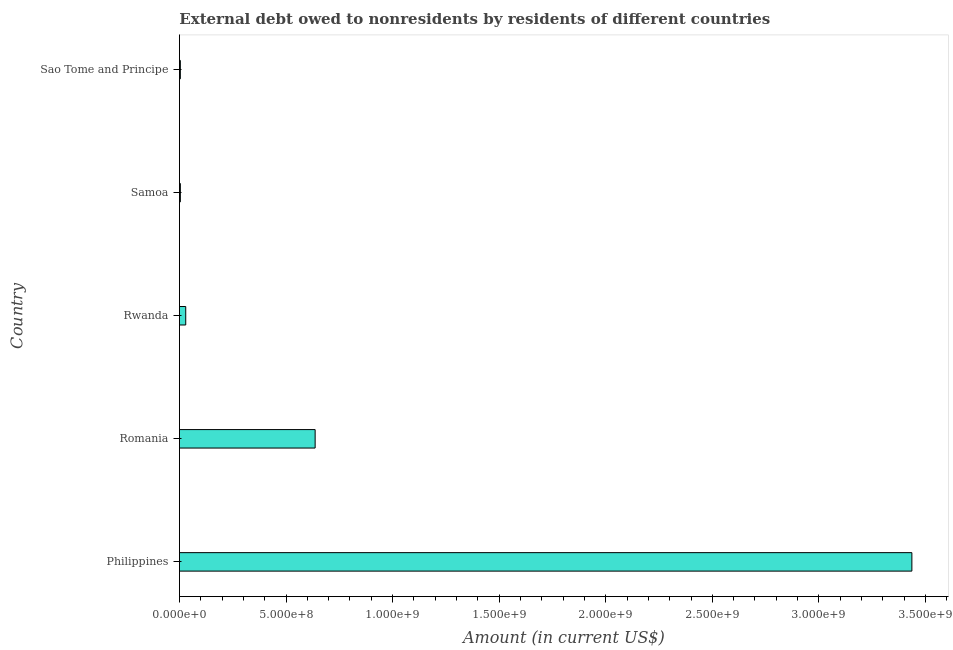Does the graph contain any zero values?
Your response must be concise. No. Does the graph contain grids?
Provide a succinct answer. No. What is the title of the graph?
Keep it short and to the point. External debt owed to nonresidents by residents of different countries. What is the label or title of the X-axis?
Offer a very short reply. Amount (in current US$). What is the debt in Romania?
Keep it short and to the point. 6.37e+08. Across all countries, what is the maximum debt?
Give a very brief answer. 3.44e+09. Across all countries, what is the minimum debt?
Your response must be concise. 4.38e+06. In which country was the debt minimum?
Offer a very short reply. Sao Tome and Principe. What is the sum of the debt?
Your response must be concise. 4.11e+09. What is the difference between the debt in Philippines and Rwanda?
Provide a short and direct response. 3.41e+09. What is the average debt per country?
Your response must be concise. 8.22e+08. What is the median debt?
Your response must be concise. 2.97e+07. What is the ratio of the debt in Philippines to that in Rwanda?
Make the answer very short. 115.87. Is the debt in Philippines less than that in Samoa?
Provide a short and direct response. No. What is the difference between the highest and the second highest debt?
Make the answer very short. 2.80e+09. What is the difference between the highest and the lowest debt?
Ensure brevity in your answer.  3.43e+09. Are all the bars in the graph horizontal?
Offer a very short reply. Yes. What is the difference between two consecutive major ticks on the X-axis?
Offer a terse response. 5.00e+08. What is the Amount (in current US$) in Philippines?
Provide a short and direct response. 3.44e+09. What is the Amount (in current US$) of Romania?
Offer a very short reply. 6.37e+08. What is the Amount (in current US$) in Rwanda?
Make the answer very short. 2.97e+07. What is the Amount (in current US$) in Samoa?
Your answer should be compact. 4.42e+06. What is the Amount (in current US$) in Sao Tome and Principe?
Provide a succinct answer. 4.38e+06. What is the difference between the Amount (in current US$) in Philippines and Romania?
Provide a short and direct response. 2.80e+09. What is the difference between the Amount (in current US$) in Philippines and Rwanda?
Your response must be concise. 3.41e+09. What is the difference between the Amount (in current US$) in Philippines and Samoa?
Your answer should be very brief. 3.43e+09. What is the difference between the Amount (in current US$) in Philippines and Sao Tome and Principe?
Your response must be concise. 3.43e+09. What is the difference between the Amount (in current US$) in Romania and Rwanda?
Your response must be concise. 6.07e+08. What is the difference between the Amount (in current US$) in Romania and Samoa?
Ensure brevity in your answer.  6.32e+08. What is the difference between the Amount (in current US$) in Romania and Sao Tome and Principe?
Make the answer very short. 6.32e+08. What is the difference between the Amount (in current US$) in Rwanda and Samoa?
Provide a short and direct response. 2.52e+07. What is the difference between the Amount (in current US$) in Rwanda and Sao Tome and Principe?
Provide a short and direct response. 2.53e+07. What is the difference between the Amount (in current US$) in Samoa and Sao Tome and Principe?
Provide a succinct answer. 4.50e+04. What is the ratio of the Amount (in current US$) in Philippines to that in Romania?
Keep it short and to the point. 5.4. What is the ratio of the Amount (in current US$) in Philippines to that in Rwanda?
Offer a terse response. 115.87. What is the ratio of the Amount (in current US$) in Philippines to that in Samoa?
Your response must be concise. 777.38. What is the ratio of the Amount (in current US$) in Philippines to that in Sao Tome and Principe?
Keep it short and to the point. 785.38. What is the ratio of the Amount (in current US$) in Romania to that in Rwanda?
Keep it short and to the point. 21.47. What is the ratio of the Amount (in current US$) in Romania to that in Samoa?
Keep it short and to the point. 144.05. What is the ratio of the Amount (in current US$) in Romania to that in Sao Tome and Principe?
Your answer should be very brief. 145.53. What is the ratio of the Amount (in current US$) in Rwanda to that in Samoa?
Provide a succinct answer. 6.71. What is the ratio of the Amount (in current US$) in Rwanda to that in Sao Tome and Principe?
Offer a terse response. 6.78. 